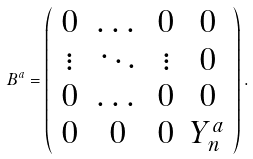<formula> <loc_0><loc_0><loc_500><loc_500>B ^ { a } = \left ( \begin{array} { c c c c } 0 & \dots & 0 & 0 \\ \vdots & \ddots & \vdots & 0 \\ 0 & \dots & 0 & 0 \\ 0 & 0 & 0 & Y _ { n } ^ { a } \end{array} \right ) .</formula> 